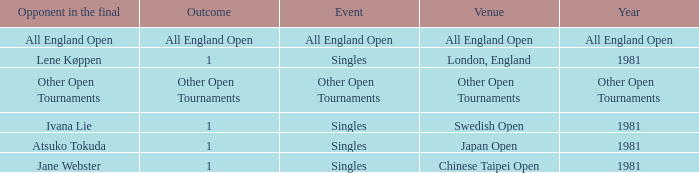What is the Opponent in final with an All England Open Outcome? All England Open. 